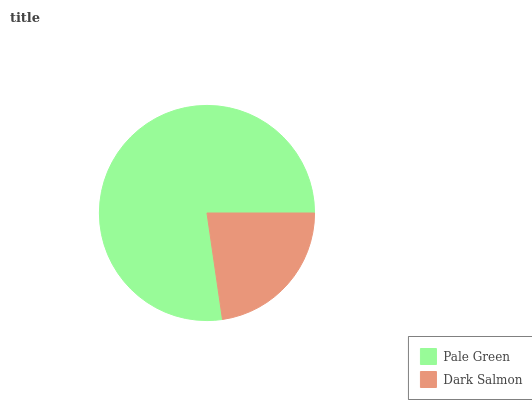Is Dark Salmon the minimum?
Answer yes or no. Yes. Is Pale Green the maximum?
Answer yes or no. Yes. Is Dark Salmon the maximum?
Answer yes or no. No. Is Pale Green greater than Dark Salmon?
Answer yes or no. Yes. Is Dark Salmon less than Pale Green?
Answer yes or no. Yes. Is Dark Salmon greater than Pale Green?
Answer yes or no. No. Is Pale Green less than Dark Salmon?
Answer yes or no. No. Is Pale Green the high median?
Answer yes or no. Yes. Is Dark Salmon the low median?
Answer yes or no. Yes. Is Dark Salmon the high median?
Answer yes or no. No. Is Pale Green the low median?
Answer yes or no. No. 